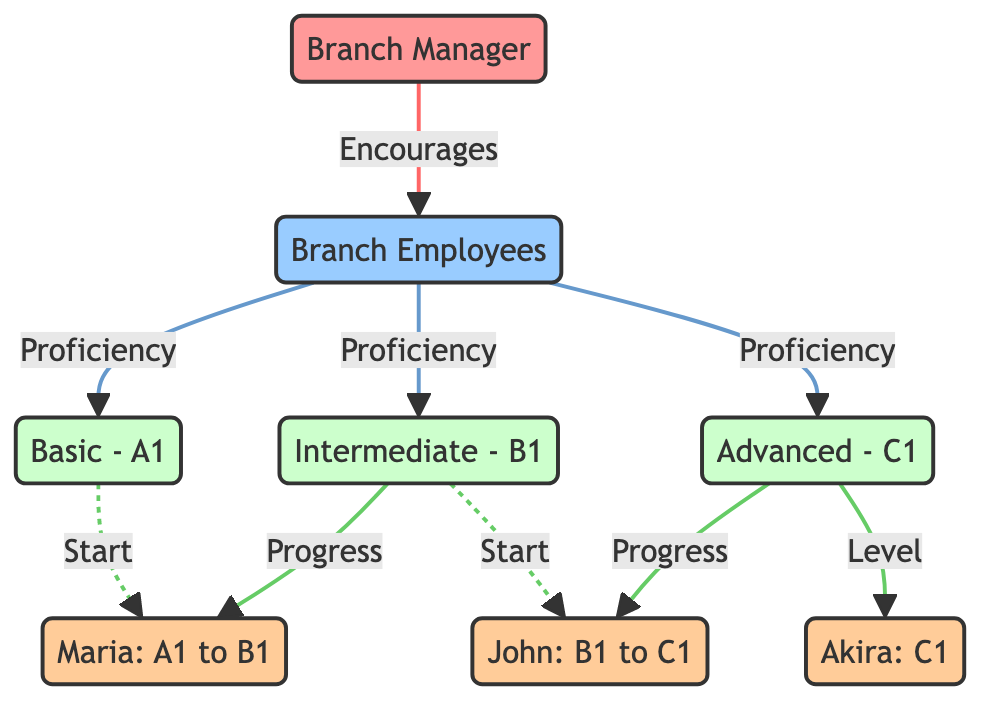What are the three language proficiency levels represented in the diagram? The diagram shows three language proficiency levels: Basic - A1, Intermediate - B1, and Advanced - C1. These are the nodes labeled with respective levels and are categorized under "Proficiency" for branch employees.
Answer: Basic - A1, Intermediate - B1, Advanced - C1 How many agents are shown in the diagram? The diagram includes three agents: Maria, John, and Akira. Each of these agents is labeled in the diagram and represents individual progress in language proficiency.
Answer: 3 Which agent is at the Advanced - C1 level? The agent identified with the Advanced - C1 level in the diagram is Akira. This information is indicated by the connection labeled "Level" for Akira leading to the C1 node.
Answer: Akira From which proficiency level did Maria progress? Maria started at the Basic - A1 level before advancing to the Intermediate - B1 level. This progression is shown by the connections leading from A1 to B1 for Maria in the diagram.
Answer: Basic - A1 Which agent's progress is indicated to move from B1 to C1? The agent whose progress is indicated to move from Intermediate - B1 to Advanced - C1 is John. This transition is shown by the arrows leading from B1 to C1 for John in the diagram.
Answer: John What does the connection labeled "Proficiency" indicate in the diagram? The "Proficiency" connection signifies that branch employees are associated with the language proficiency levels represented in the diagram. It is an overarching connection linking employees to the various levels they can achieve.
Answer: Language Proficiency Levels Which language proficiency level did John start from? John started from the Intermediate - B1 level, as shown in the diagram where the line connecting him originates at the B1 node with a "Start" label leading to his further progression.
Answer: Intermediate - B1 How many unique relationships can be observed in the diagram? There are a total of seven unique relationships observed in the diagram, considering both direct progressions by agents and connections to proficiency levels and the branch manager.
Answer: 7 